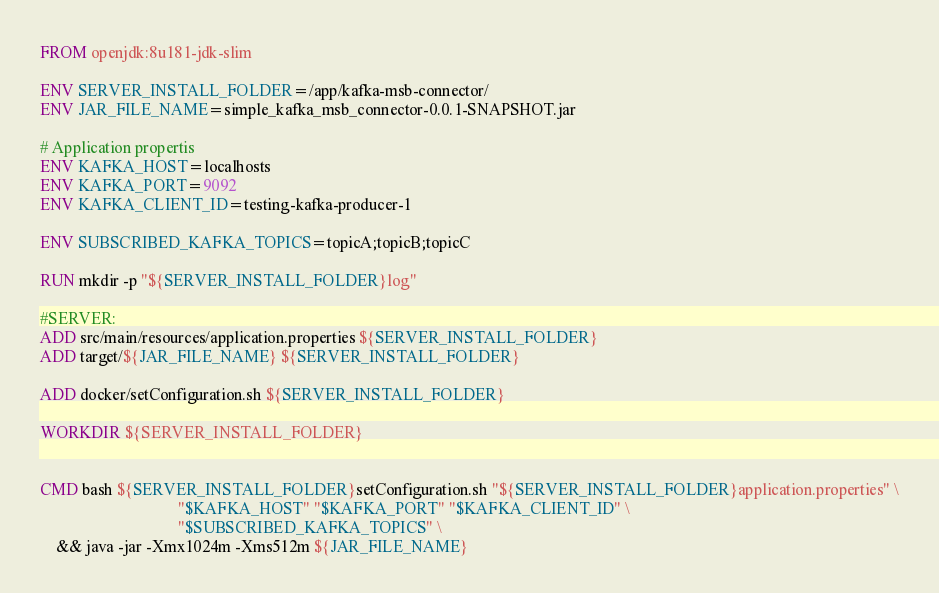Convert code to text. <code><loc_0><loc_0><loc_500><loc_500><_Dockerfile_>FROM openjdk:8u181-jdk-slim

ENV SERVER_INSTALL_FOLDER=/app/kafka-msb-connector/
ENV JAR_FILE_NAME=simple_kafka_msb_connector-0.0.1-SNAPSHOT.jar

# Application propertis
ENV KAFKA_HOST=localhosts
ENV KAFKA_PORT=9092
ENV KAFKA_CLIENT_ID=testing-kafka-producer-1

ENV SUBSCRIBED_KAFKA_TOPICS=topicA;topicB;topicC

RUN mkdir -p "${SERVER_INSTALL_FOLDER}log"

#SERVER:
ADD src/main/resources/application.properties ${SERVER_INSTALL_FOLDER}
ADD target/${JAR_FILE_NAME} ${SERVER_INSTALL_FOLDER}

ADD docker/setConfiguration.sh ${SERVER_INSTALL_FOLDER}

WORKDIR ${SERVER_INSTALL_FOLDER}


CMD bash ${SERVER_INSTALL_FOLDER}setConfiguration.sh "${SERVER_INSTALL_FOLDER}application.properties" \
                                  "$KAFKA_HOST" "$KAFKA_PORT" "$KAFKA_CLIENT_ID" \
                                  "$SUBSCRIBED_KAFKA_TOPICS" \
    && java -jar -Xmx1024m -Xms512m ${JAR_FILE_NAME}

</code> 